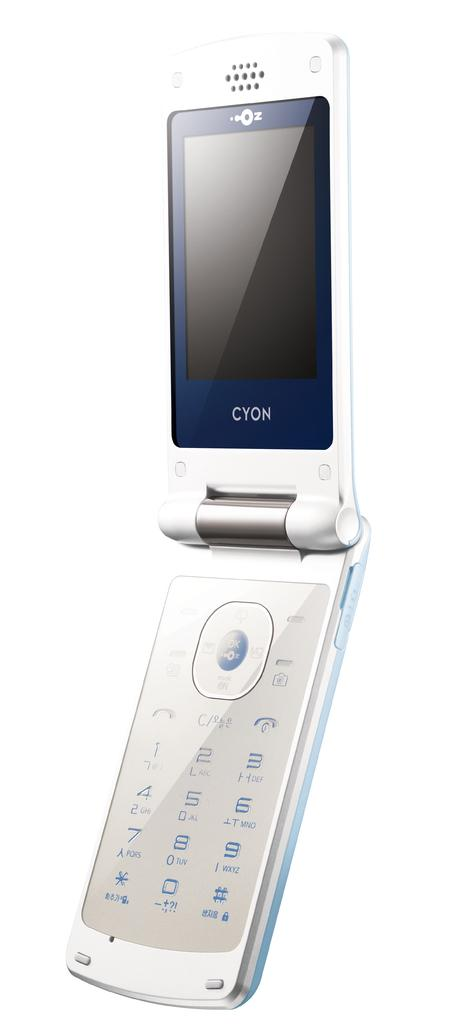<image>
Write a terse but informative summary of the picture. A white flip cellphone from Cyon with a white background. 